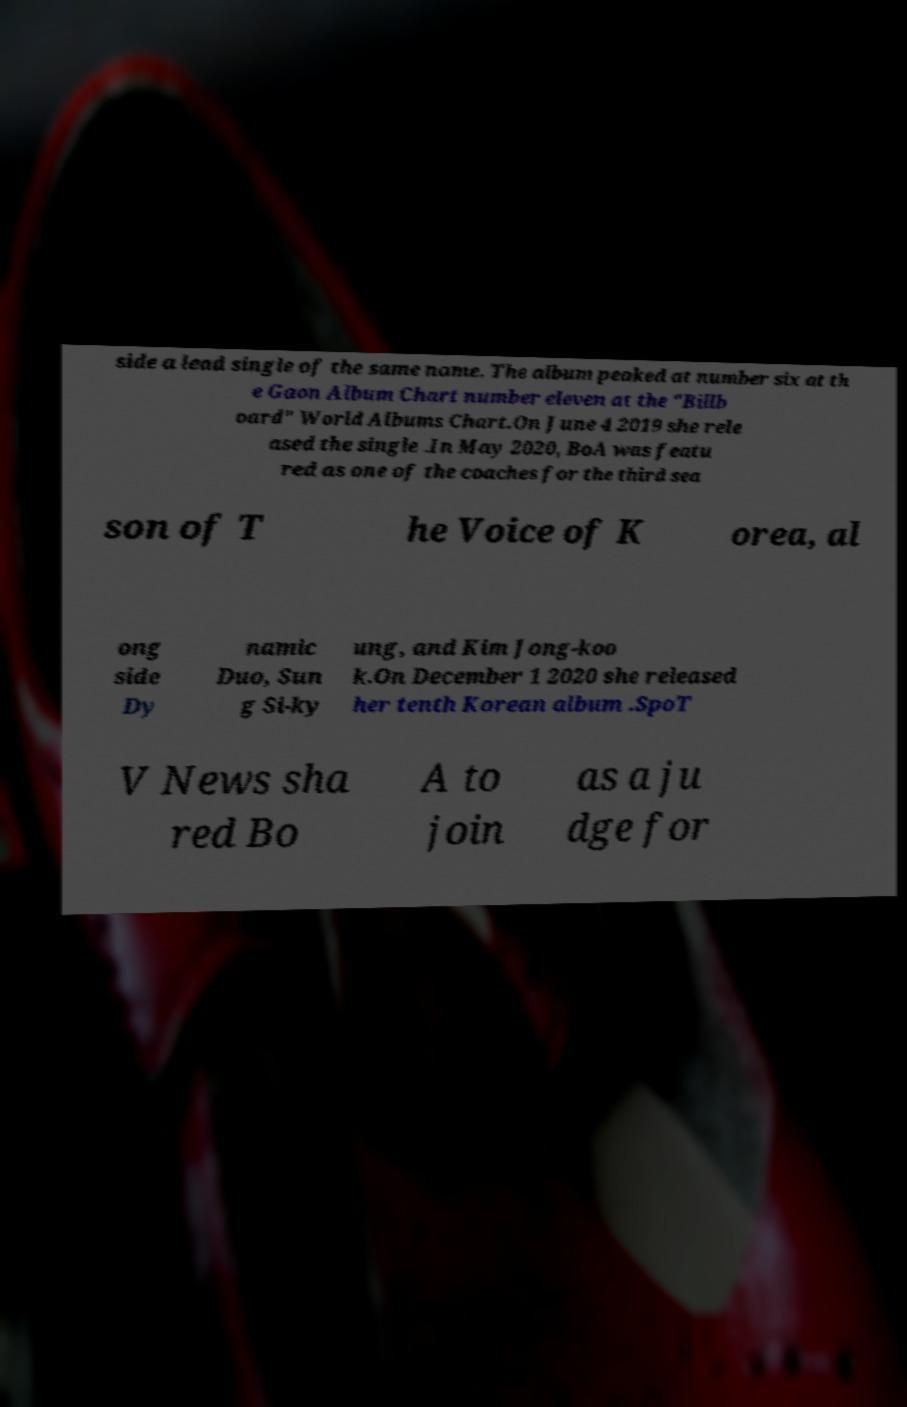What messages or text are displayed in this image? I need them in a readable, typed format. side a lead single of the same name. The album peaked at number six at th e Gaon Album Chart number eleven at the "Billb oard" World Albums Chart.On June 4 2019 she rele ased the single .In May 2020, BoA was featu red as one of the coaches for the third sea son of T he Voice of K orea, al ong side Dy namic Duo, Sun g Si-ky ung, and Kim Jong-koo k.On December 1 2020 she released her tenth Korean album .SpoT V News sha red Bo A to join as a ju dge for 